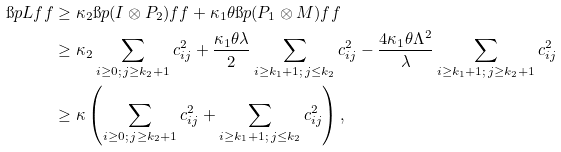Convert formula to latex. <formula><loc_0><loc_0><loc_500><loc_500>\i p { L f } { f } & \geq \kappa _ { 2 } \i p { ( I \otimes P _ { 2 } ) f } { f } + \kappa _ { 1 } \theta \i p { ( P _ { 1 } \otimes M ) f } { f } \\ & \geq \kappa _ { 2 } \sum _ { i \geq 0 ; \, j \geq k _ { 2 } + 1 } c _ { i j } ^ { 2 } + \frac { \kappa _ { 1 } \theta \lambda } 2 \sum _ { i \geq k _ { 1 } + 1 ; \, j \leq k _ { 2 } } c _ { i j } ^ { 2 } - \frac { 4 \kappa _ { 1 } \theta \Lambda ^ { 2 } } { \lambda } \sum _ { i \geq k _ { 1 } + 1 ; \, j \geq k _ { 2 } + 1 } c _ { i j } ^ { 2 } \\ & \geq \kappa \left ( \sum _ { i \geq 0 ; \, j \geq k _ { 2 } + 1 } c _ { i j } ^ { 2 } + \sum _ { i \geq k _ { 1 } + 1 ; \, j \leq k _ { 2 } } c _ { i j } ^ { 2 } \right ) ,</formula> 